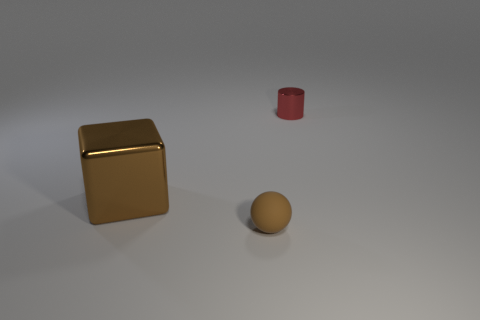Add 1 cylinders. How many objects exist? 4 Subtract all cubes. How many objects are left? 2 Add 1 red objects. How many red objects are left? 2 Add 2 tiny blue metallic things. How many tiny blue metallic things exist? 2 Subtract 0 yellow spheres. How many objects are left? 3 Subtract all matte balls. Subtract all small brown spheres. How many objects are left? 1 